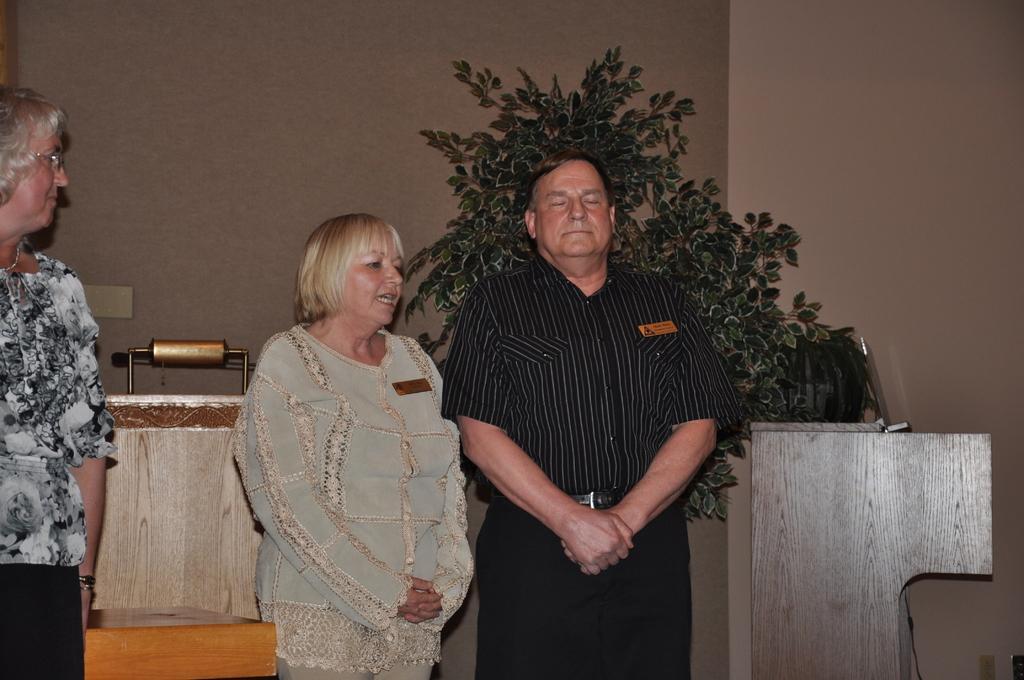In one or two sentences, can you explain what this image depicts? In this image we can see three persons are standing. In the background we can see a board on the wall, plants, wooden objects and we can see other objects. 